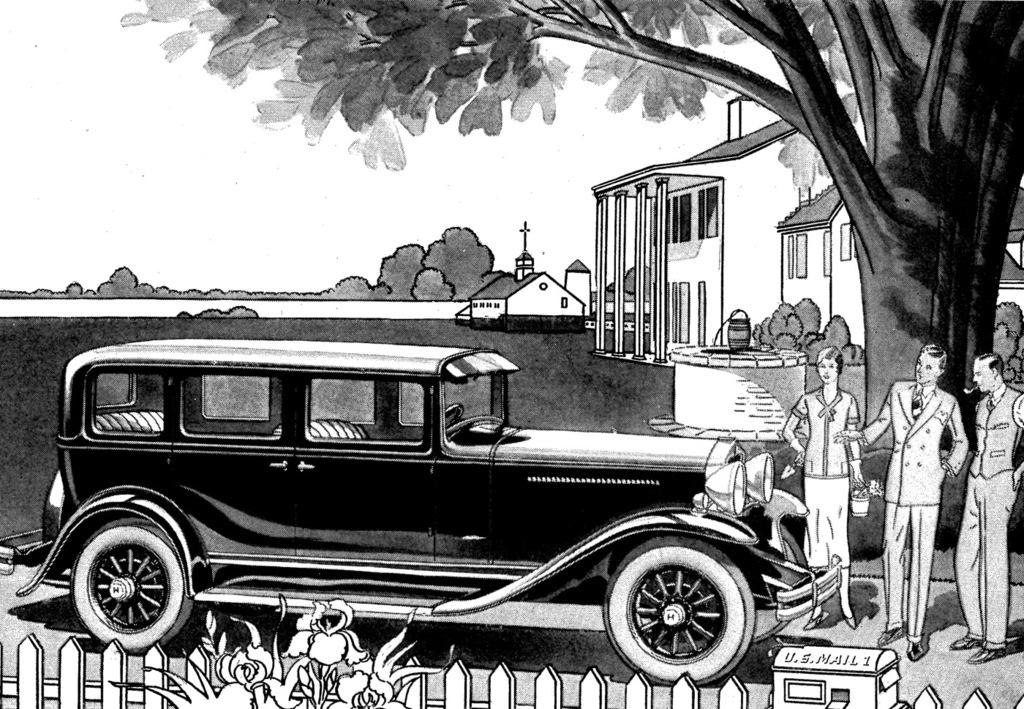What is depicted in the drawing in the image? There is a drawing of a fence, plants, trees, and a car in the image. Are there any living organisms in the drawing? Yes, there are plants and trees depicted in the drawing. What is the mode of transportation shown in the drawing? There is a drawing of a car in the image. How many people are present in the drawing? There are three people standing on the right side in the drawing. What type of hospital can be seen in the drawing? There is no hospital depicted in the drawing; it features a fence, plants, trees, a car, and three people. How does the paste help in the drawing? There is no mention of paste in the drawing or the provided facts, so it cannot be determined how it might help. 